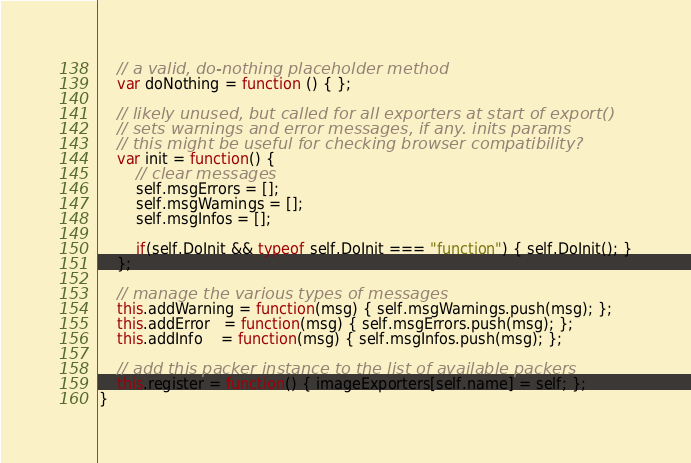<code> <loc_0><loc_0><loc_500><loc_500><_JavaScript_>	// a valid, do-nothing placeholder method
	var doNothing = function () { };
	
	// likely unused, but called for all exporters at start of export()
	// sets warnings and error messages, if any. inits params
	// this might be useful for checking browser compatibility?
	var init = function() { 
		// clear messages
		self.msgErrors = [];
		self.msgWarnings = [];
		self.msgInfos = [];
		
		if(self.DoInit && typeof self.DoInit === "function") { self.DoInit(); }
	};
	
	// manage the various types of messages
	this.addWarning = function(msg) { self.msgWarnings.push(msg); };
	this.addError   = function(msg) { self.msgErrors.push(msg); };
	this.addInfo    = function(msg) { self.msgInfos.push(msg); };

	// add this packer instance to the list of available packers
	this.register = function() { imageExporters[self.name] = self; };
}
</code> 